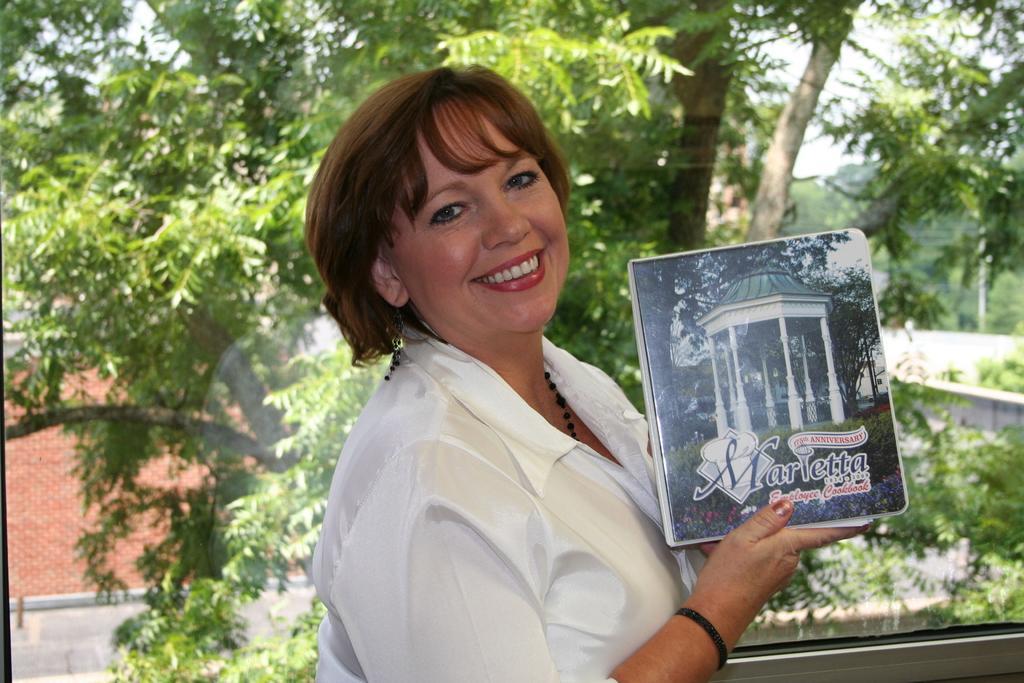In one or two sentences, can you explain what this image depicts? This picture shows a woman standing and holding a book in her hand. She wore a white color shirt with a smile on her face and we see trees and a house. 